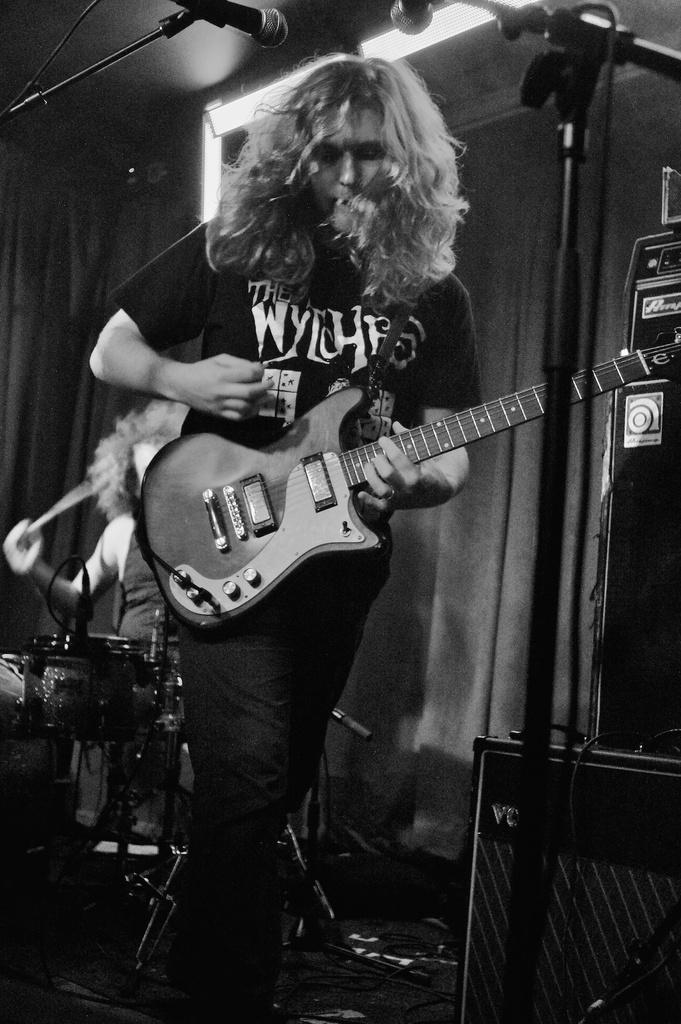Who is the main subject in the image? The main subject in the image is a girl. What is the girl wearing? The girl is wearing a black shirt and black pants. What is the girl holding in the image? The girl is holding a guitar. What is the girl doing with the guitar? The girl is playing the guitar. Where is the girl positioned in the image? The girl is in front of a microphone. Who else is present in the image? There is also a man in the image. What is the man doing in the image? The man is playing the drums. What type of banana is the girl holding in the image? There is no banana present in the image; the girl is holding a guitar. Who is the representative of the band in the image? The image does not indicate any specific roles or positions within a band, so it cannot be determined who the representative is. 